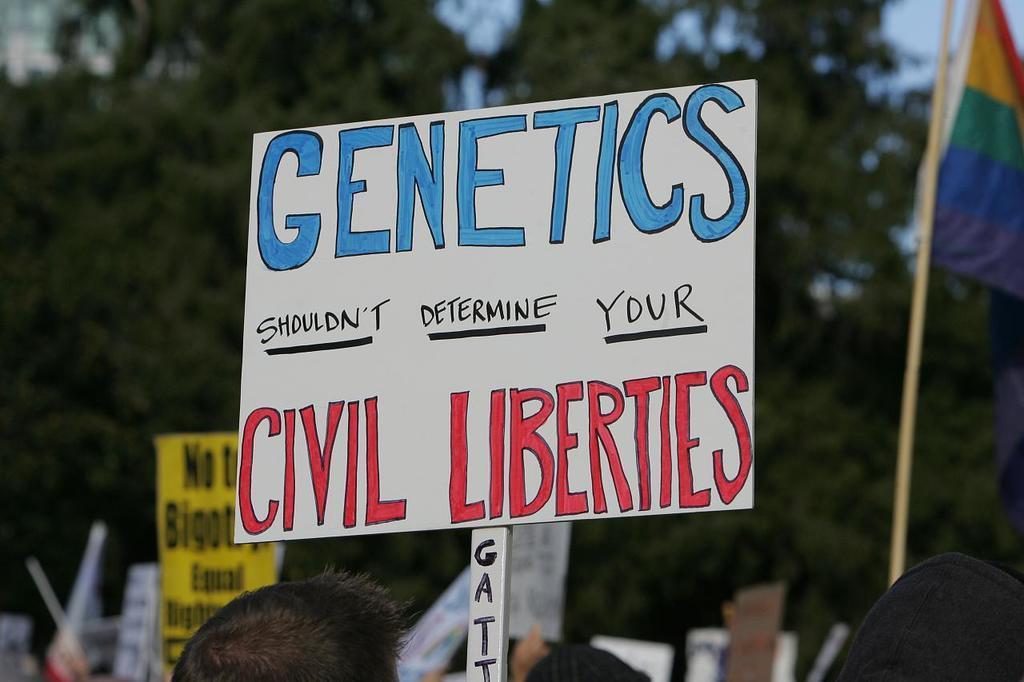Can you describe this image briefly? In this image, there is a white color board, on that there is GENETICS SHOULDN'T DETERMINE YOUR CIVIL LIBERTIES written, at the background there are some green color trees. 